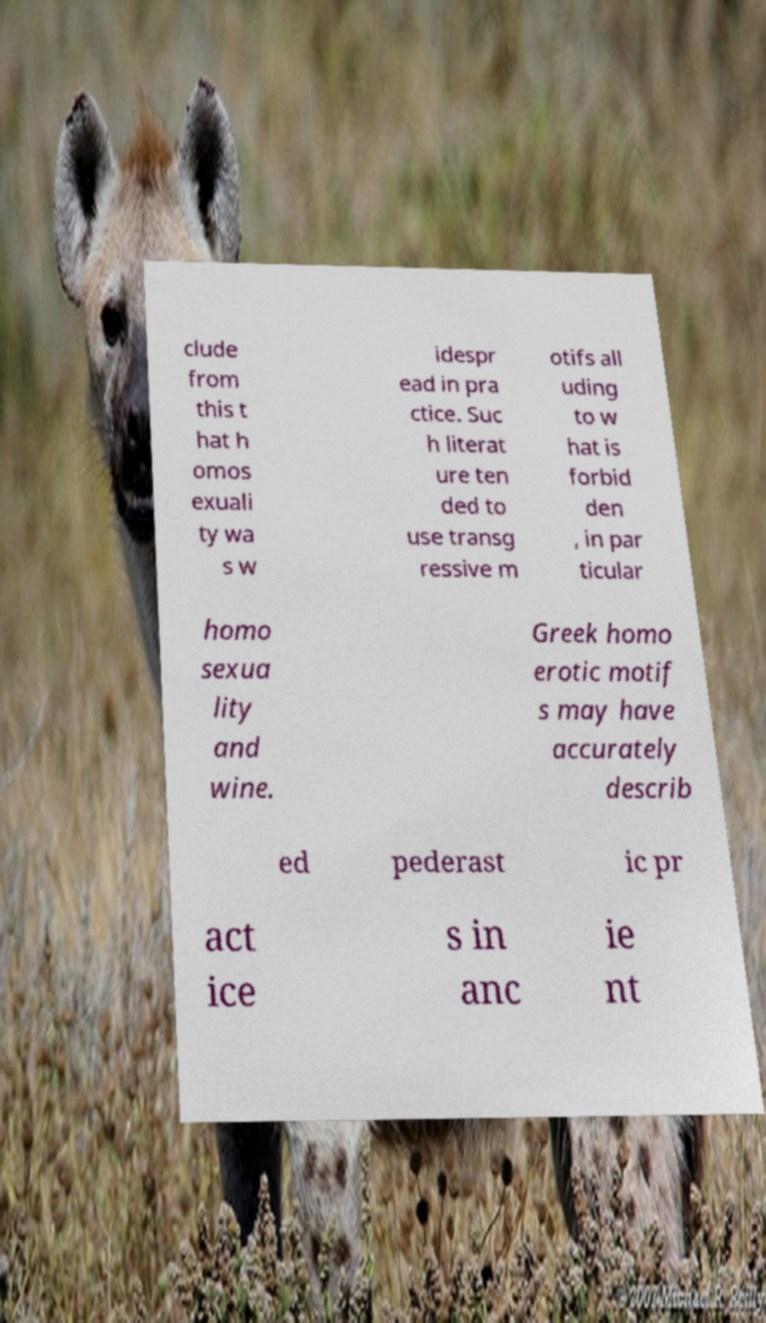There's text embedded in this image that I need extracted. Can you transcribe it verbatim? clude from this t hat h omos exuali ty wa s w idespr ead in pra ctice. Suc h literat ure ten ded to use transg ressive m otifs all uding to w hat is forbid den , in par ticular homo sexua lity and wine. Greek homo erotic motif s may have accurately describ ed pederast ic pr act ice s in anc ie nt 